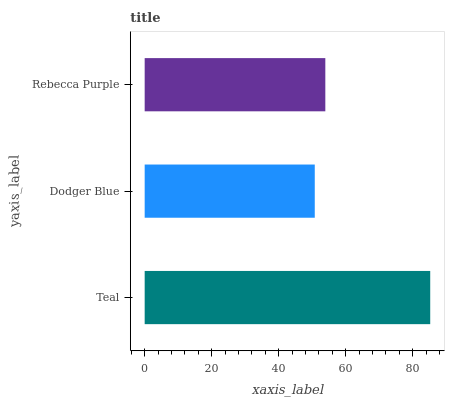Is Dodger Blue the minimum?
Answer yes or no. Yes. Is Teal the maximum?
Answer yes or no. Yes. Is Rebecca Purple the minimum?
Answer yes or no. No. Is Rebecca Purple the maximum?
Answer yes or no. No. Is Rebecca Purple greater than Dodger Blue?
Answer yes or no. Yes. Is Dodger Blue less than Rebecca Purple?
Answer yes or no. Yes. Is Dodger Blue greater than Rebecca Purple?
Answer yes or no. No. Is Rebecca Purple less than Dodger Blue?
Answer yes or no. No. Is Rebecca Purple the high median?
Answer yes or no. Yes. Is Rebecca Purple the low median?
Answer yes or no. Yes. Is Dodger Blue the high median?
Answer yes or no. No. Is Dodger Blue the low median?
Answer yes or no. No. 